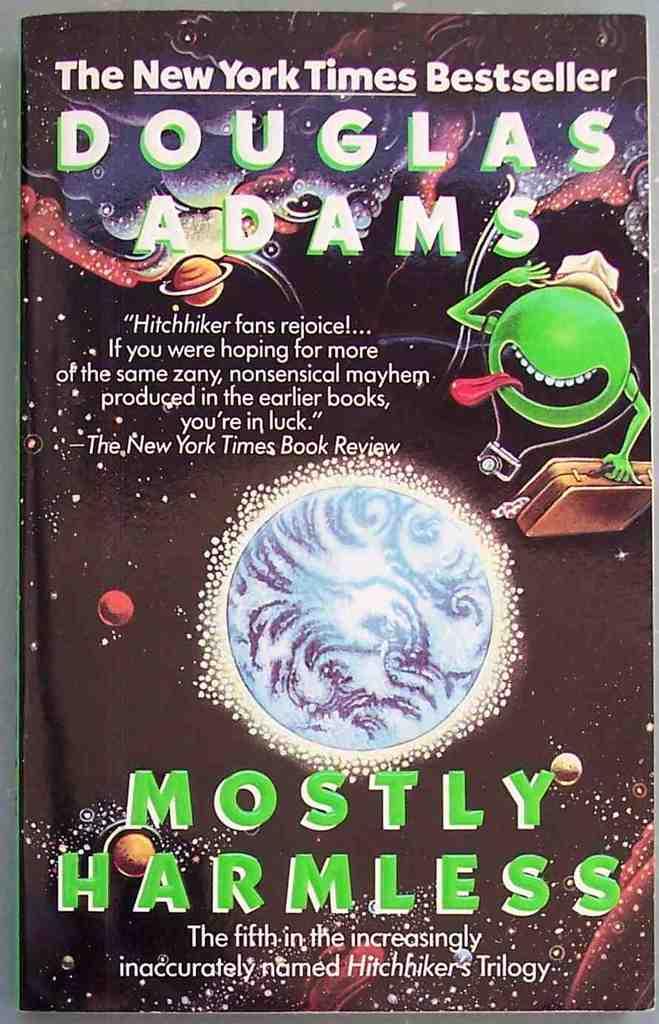What is the bestseller?
Offer a terse response. Mostly harmless. Who wrote this book?
Your answer should be very brief. Douglas adams. 